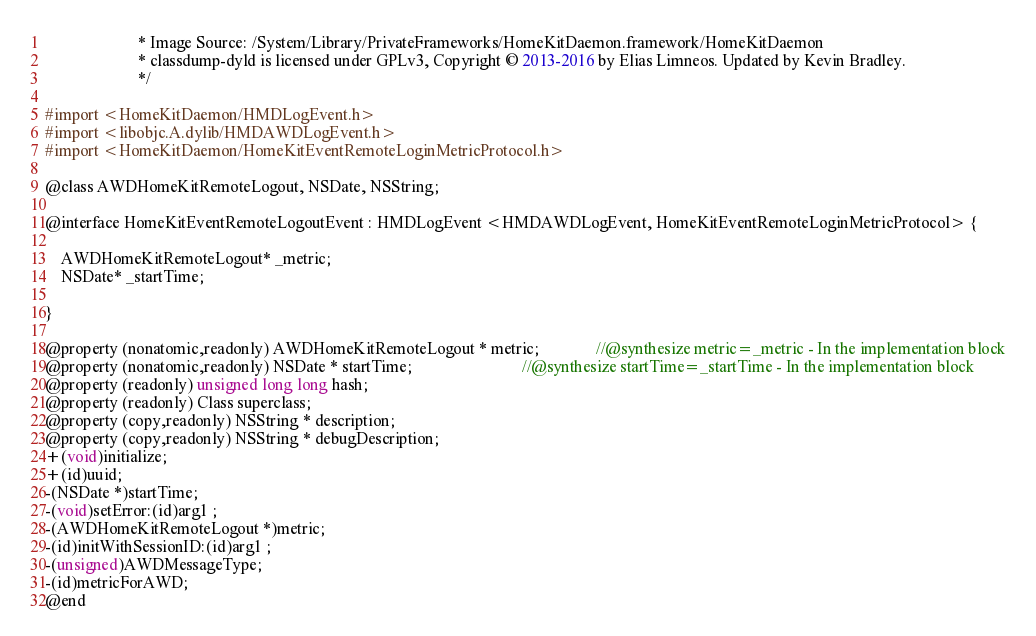<code> <loc_0><loc_0><loc_500><loc_500><_C_>                       * Image Source: /System/Library/PrivateFrameworks/HomeKitDaemon.framework/HomeKitDaemon
                       * classdump-dyld is licensed under GPLv3, Copyright © 2013-2016 by Elias Limneos. Updated by Kevin Bradley.
                       */

#import <HomeKitDaemon/HMDLogEvent.h>
#import <libobjc.A.dylib/HMDAWDLogEvent.h>
#import <HomeKitDaemon/HomeKitEventRemoteLoginMetricProtocol.h>

@class AWDHomeKitRemoteLogout, NSDate, NSString;

@interface HomeKitEventRemoteLogoutEvent : HMDLogEvent <HMDAWDLogEvent, HomeKitEventRemoteLoginMetricProtocol> {

	AWDHomeKitRemoteLogout* _metric;
	NSDate* _startTime;

}

@property (nonatomic,readonly) AWDHomeKitRemoteLogout * metric;              //@synthesize metric=_metric - In the implementation block
@property (nonatomic,readonly) NSDate * startTime;                           //@synthesize startTime=_startTime - In the implementation block
@property (readonly) unsigned long long hash; 
@property (readonly) Class superclass; 
@property (copy,readonly) NSString * description; 
@property (copy,readonly) NSString * debugDescription; 
+(void)initialize;
+(id)uuid;
-(NSDate *)startTime;
-(void)setError:(id)arg1 ;
-(AWDHomeKitRemoteLogout *)metric;
-(id)initWithSessionID:(id)arg1 ;
-(unsigned)AWDMessageType;
-(id)metricForAWD;
@end

</code> 